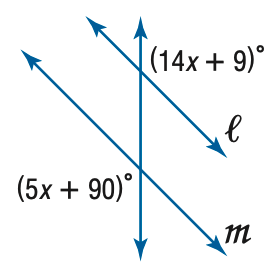Question: Find x so that m \parallel n.
Choices:
A. 9
B. 10
C. 11
D. 12
Answer with the letter. Answer: A 